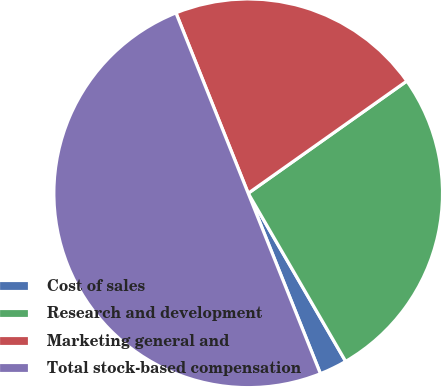Convert chart. <chart><loc_0><loc_0><loc_500><loc_500><pie_chart><fcel>Cost of sales<fcel>Research and development<fcel>Marketing general and<fcel>Total stock-based compensation<nl><fcel>2.3%<fcel>26.44%<fcel>21.26%<fcel>50.0%<nl></chart> 